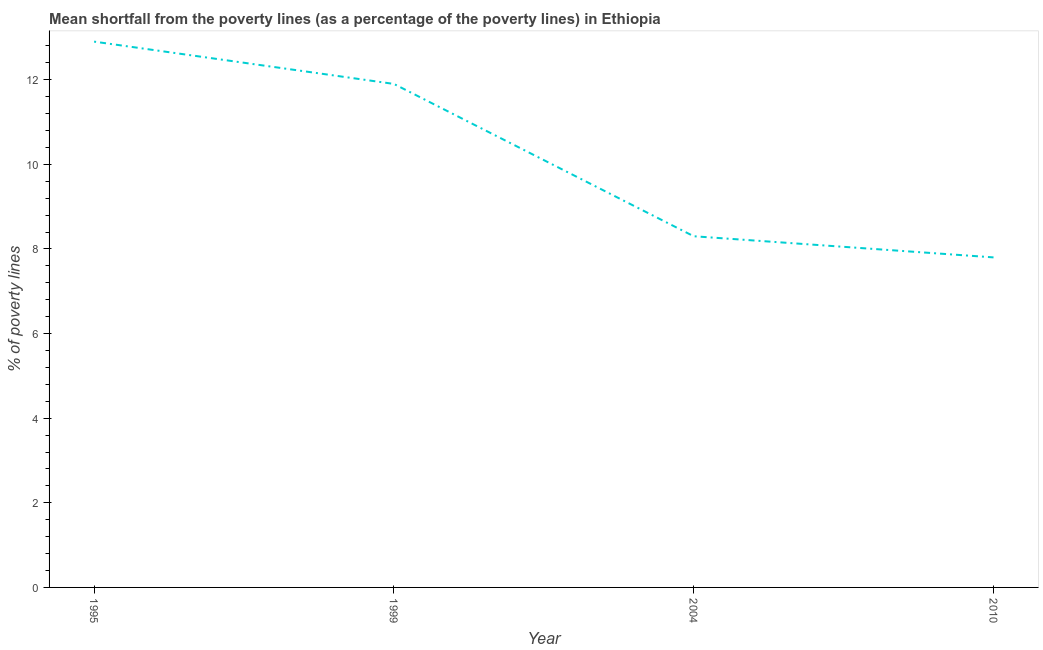Across all years, what is the minimum poverty gap at national poverty lines?
Offer a very short reply. 7.8. What is the sum of the poverty gap at national poverty lines?
Your answer should be very brief. 40.9. What is the difference between the poverty gap at national poverty lines in 1995 and 1999?
Your answer should be very brief. 1. What is the average poverty gap at national poverty lines per year?
Your answer should be compact. 10.22. What is the median poverty gap at national poverty lines?
Your answer should be very brief. 10.1. Do a majority of the years between 1995 and 2010 (inclusive) have poverty gap at national poverty lines greater than 7.6 %?
Provide a succinct answer. Yes. What is the ratio of the poverty gap at national poverty lines in 1999 to that in 2010?
Your answer should be very brief. 1.53. Is the poverty gap at national poverty lines in 1995 less than that in 2010?
Provide a short and direct response. No. What is the difference between the highest and the second highest poverty gap at national poverty lines?
Keep it short and to the point. 1. Is the sum of the poverty gap at national poverty lines in 1999 and 2010 greater than the maximum poverty gap at national poverty lines across all years?
Provide a succinct answer. Yes. What is the difference between the highest and the lowest poverty gap at national poverty lines?
Provide a succinct answer. 5.1. Does the poverty gap at national poverty lines monotonically increase over the years?
Provide a short and direct response. No. Does the graph contain any zero values?
Your answer should be compact. No. Does the graph contain grids?
Provide a short and direct response. No. What is the title of the graph?
Offer a terse response. Mean shortfall from the poverty lines (as a percentage of the poverty lines) in Ethiopia. What is the label or title of the Y-axis?
Offer a very short reply. % of poverty lines. What is the % of poverty lines in 1995?
Offer a very short reply. 12.9. What is the % of poverty lines of 2004?
Offer a very short reply. 8.3. What is the difference between the % of poverty lines in 1995 and 2004?
Provide a succinct answer. 4.6. What is the difference between the % of poverty lines in 1995 and 2010?
Offer a terse response. 5.1. What is the difference between the % of poverty lines in 1999 and 2004?
Ensure brevity in your answer.  3.6. What is the difference between the % of poverty lines in 2004 and 2010?
Offer a very short reply. 0.5. What is the ratio of the % of poverty lines in 1995 to that in 1999?
Your answer should be compact. 1.08. What is the ratio of the % of poverty lines in 1995 to that in 2004?
Make the answer very short. 1.55. What is the ratio of the % of poverty lines in 1995 to that in 2010?
Ensure brevity in your answer.  1.65. What is the ratio of the % of poverty lines in 1999 to that in 2004?
Keep it short and to the point. 1.43. What is the ratio of the % of poverty lines in 1999 to that in 2010?
Your response must be concise. 1.53. What is the ratio of the % of poverty lines in 2004 to that in 2010?
Give a very brief answer. 1.06. 